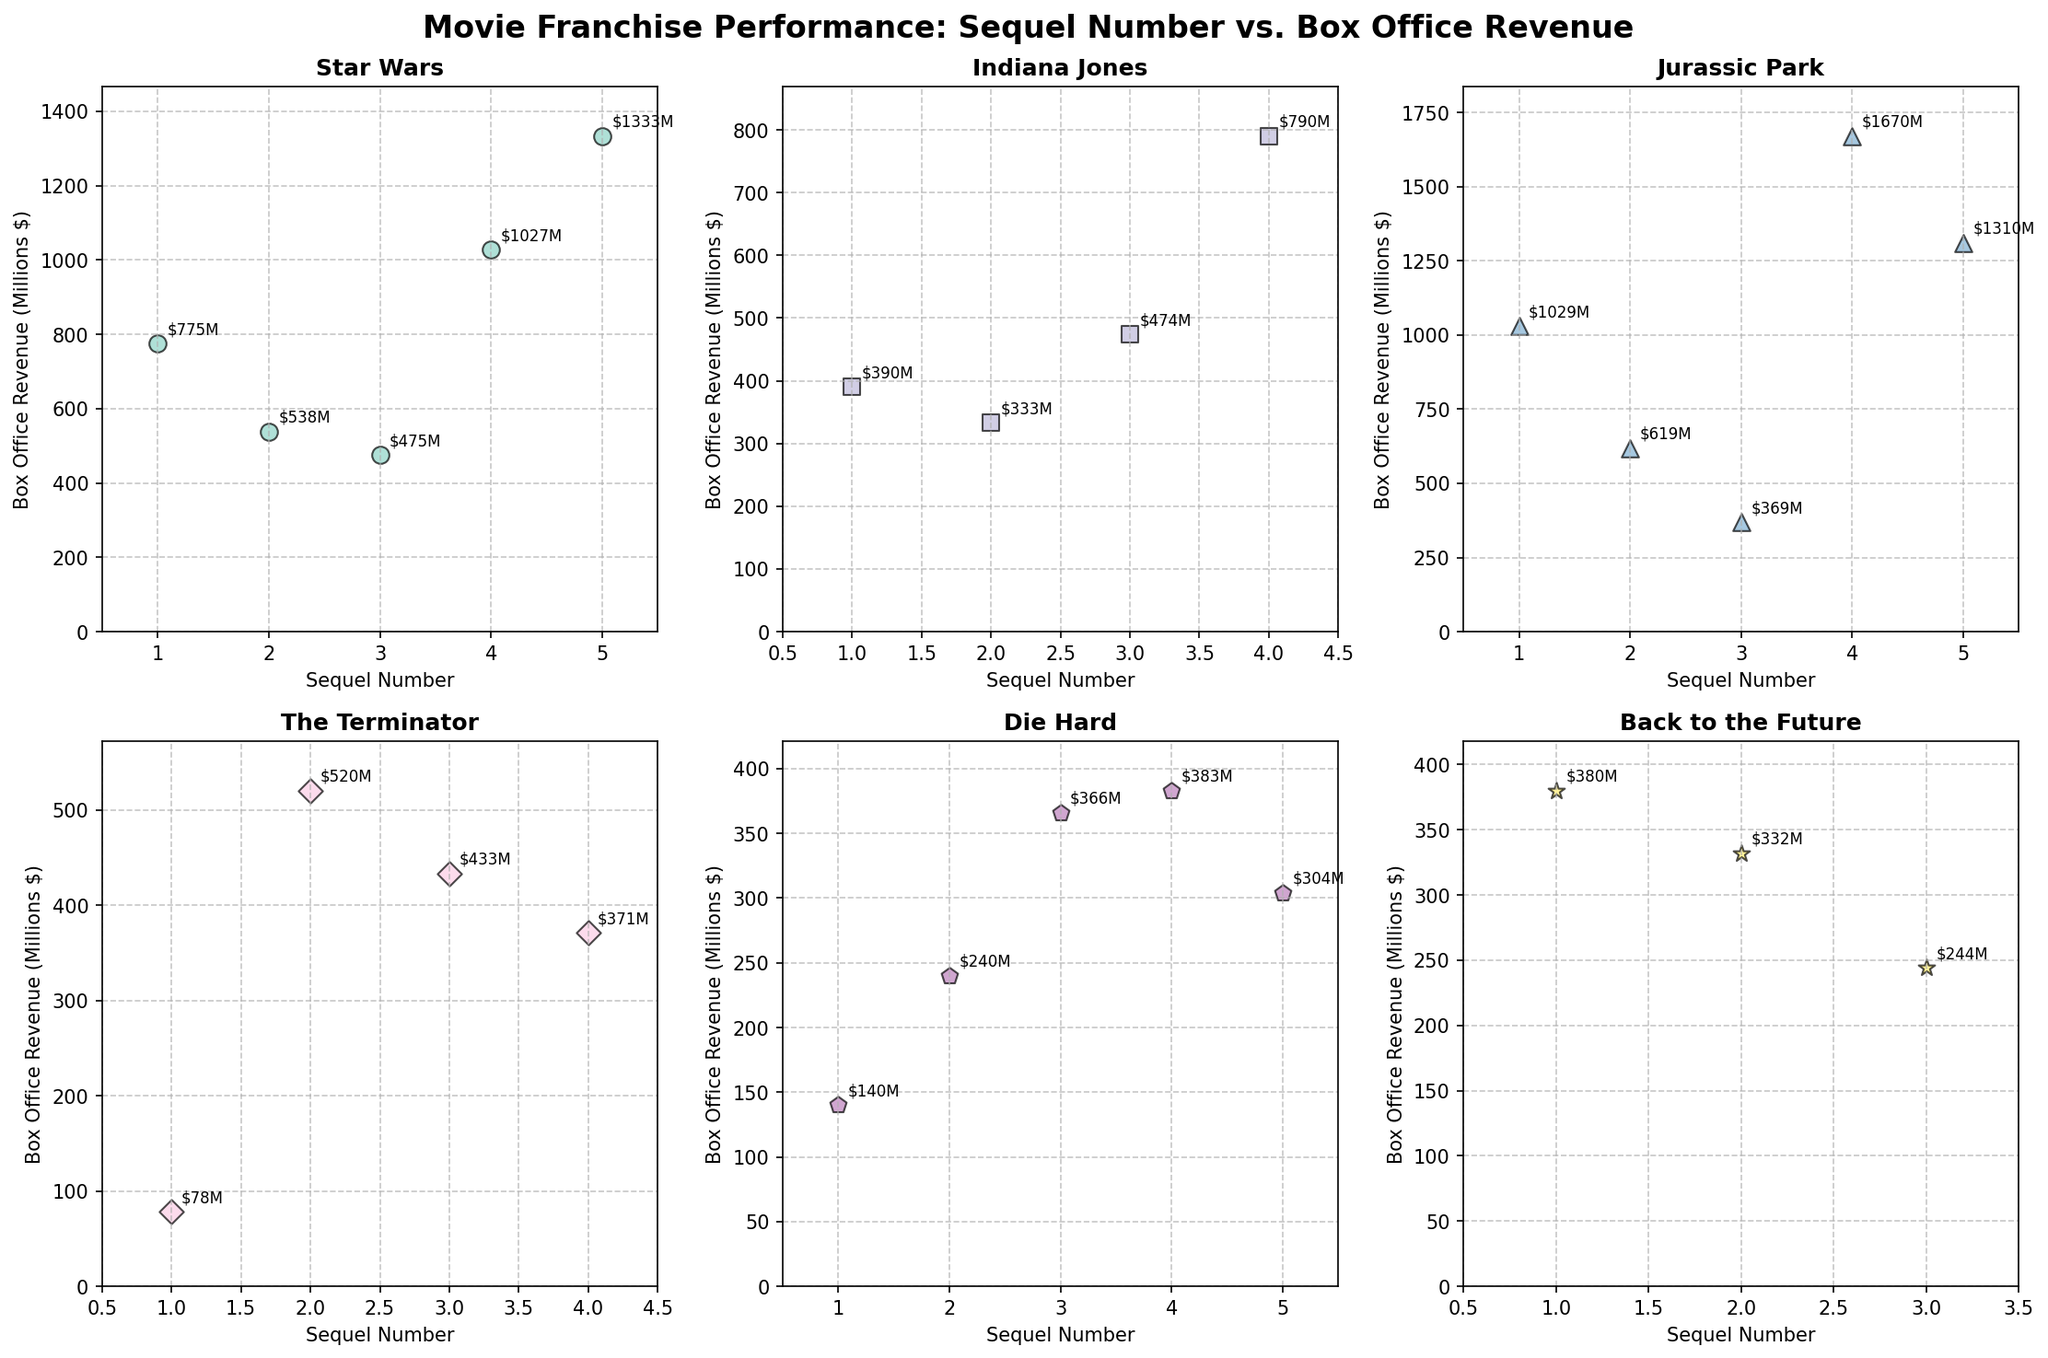What's the title of the overall figure? Look at the top of the figure where the main title is displayed.
Answer: Movie Franchise Performance: Sequel Number vs. Box Office Revenue Which franchise has the highest box office revenue for a single film? Identify the points with the highest value in the y-axis across all subplots.
Answer: Jurassic Park What is the trend in box office revenue for Star Wars sequels? Observe the plot for Star Wars and see if the revenue generally increases or decreases with sequel number.
Answer: Trend upward then downward How many sequels does the Indiana Jones franchise have in the plot? Count the number of data points in the Indiana Jones subplot.
Answer: Four Which sequel number has the lowest box office revenue in the Die Hard franchise? Find the minimum y-value point in the Die Hard subplot and note its x-value.
Answer: Five What is the average box office revenue for the Back to the Future franchise? Sum the box office revenues for Back to the Future and divide by the number of sequels. ($380M + $332M + $244M) / 3 = $318.67M
Answer: $318.67M Compare the box office revenue of Jurassic Park's third and fourth sequels. Look at the data points for Jurassic Park’s 3rd and 4th sequels and compare their y-values.
Answer: Jurassic Park 4 is higher Which franchise shows the most significant jump in revenue between two sequels? Check all sequels' revenue differences within each franchise and identify the largest gap.
Answer: Jurassic Park between 3rd and 4th What is the box office revenue range for The Terminator franchise? Determine the maximum and minimum box office revenue for The Terminator and calculate the difference. Max ($520M) - Min ($78M) = $442M
Answer: $442M How does the performance of Indiana Jones' fourth sequel compare to the first sequel of Star Wars? Compare the y-values of Indiana Jones’ 4th sequel and Star Wars’ 1st sequel.
Answer: Star Wars 1 is higher 